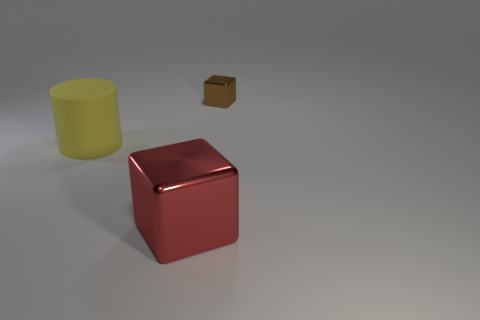Are there any other things that have the same size as the brown object?
Give a very brief answer. No. Is the number of small metal cubes that are to the left of the small cube less than the number of large red cubes on the right side of the large yellow rubber cylinder?
Provide a succinct answer. Yes. What number of things are large yellow rubber cylinders or metallic blocks behind the red metallic object?
Provide a short and direct response. 2. There is a cube that is the same size as the matte thing; what material is it?
Your answer should be compact. Metal. Is the small brown cube made of the same material as the large block?
Provide a short and direct response. Yes. There is a thing that is both behind the red metal thing and to the left of the brown cube; what color is it?
Provide a succinct answer. Yellow. There is a red thing that is the same size as the yellow cylinder; what is its shape?
Provide a short and direct response. Cube. What number of other objects are there of the same color as the small thing?
Offer a very short reply. 0. What number of other things are there of the same material as the large cylinder
Your response must be concise. 0. There is a red object; is it the same size as the metal thing that is behind the large yellow thing?
Your answer should be compact. No. 